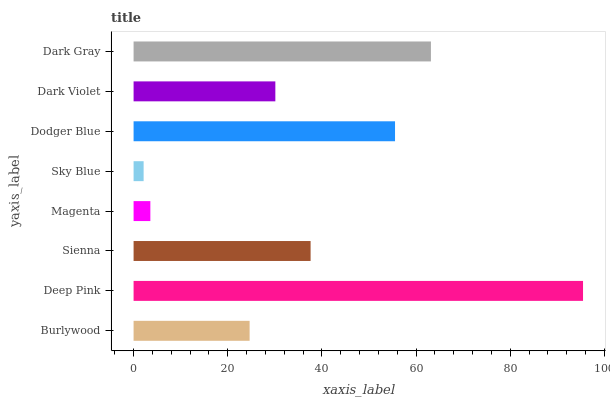Is Sky Blue the minimum?
Answer yes or no. Yes. Is Deep Pink the maximum?
Answer yes or no. Yes. Is Sienna the minimum?
Answer yes or no. No. Is Sienna the maximum?
Answer yes or no. No. Is Deep Pink greater than Sienna?
Answer yes or no. Yes. Is Sienna less than Deep Pink?
Answer yes or no. Yes. Is Sienna greater than Deep Pink?
Answer yes or no. No. Is Deep Pink less than Sienna?
Answer yes or no. No. Is Sienna the high median?
Answer yes or no. Yes. Is Dark Violet the low median?
Answer yes or no. Yes. Is Dark Violet the high median?
Answer yes or no. No. Is Deep Pink the low median?
Answer yes or no. No. 